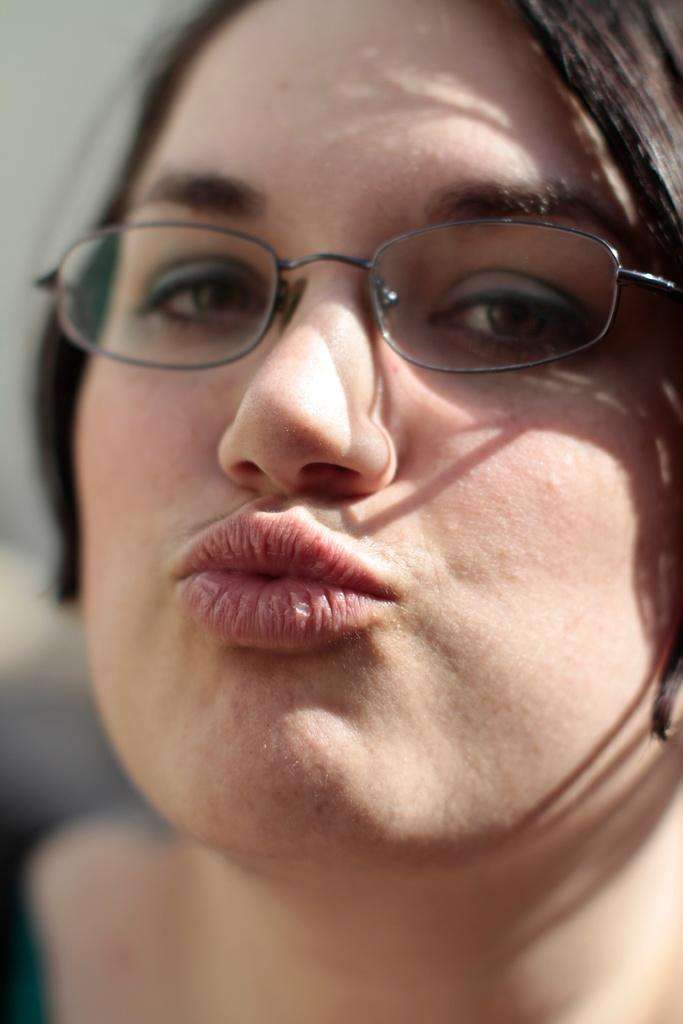What is the main subject of the image? The main subject of the image is a woman. What expression does the woman have in the image? The woman is giving a pouty expression. What is the woman's brother's health condition in the image? There is no information about the woman's brother or his health condition in the image. Is the woman in jail in the image? There is no indication that the woman is in jail in the image. 